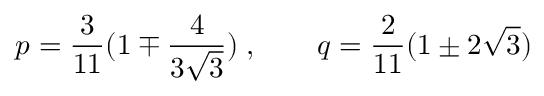Convert formula to latex. <formula><loc_0><loc_0><loc_500><loc_500>p = \frac { 3 } { 1 1 } ( 1 \mp \frac { 4 } { 3 \sqrt { 3 } } ) \, , \quad q = \frac { 2 } { 1 1 } ( 1 \pm 2 \sqrt { 3 } )</formula> 